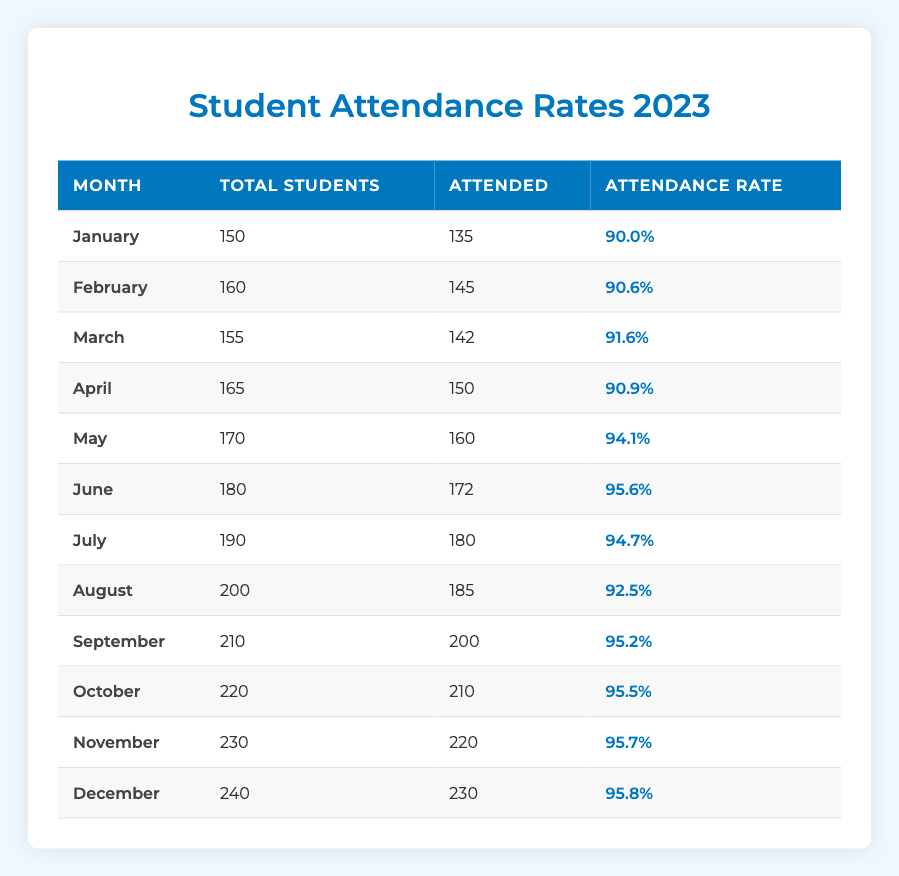What is the attendance rate for March? In the "March" row, the "Attendance Rate" is listed as 91.6%.
Answer: 91.6% How many students attended in June? The "Attended" column for "June" shows the value 172.
Answer: 172 What is the average attendance rate from January to April? The attendance rates for January to April are 90.0%, 90.6%, 91.6%, and 90.9%. Summing these gives 90.0 + 90.6 + 91.6 + 90.9 = 363.1. There are 4 months, so the average is 363.1 / 4 = 90.775%.
Answer: 90.775% Did student attendance peak in October? Looking at the "Attended" column, October has 210 students attended while November has 220. Therefore, October did not have the highest attendance.
Answer: No What is the total number of students who attended in the second half of the year (July to December)? The attended numbers for July to December are 180, 185, 200, 210, 220, and 230, respectively. Adding these gives 180 + 185 + 200 + 210 + 220 + 230 = 1225.
Answer: 1225 Was the attendance rate in May higher than that in January? The attendance rate for May is 94.1% and for January it is 90.0%. Since 94.1% is greater than 90.0%, May had a higher attendance rate.
Answer: Yes What percentage of students attended in December compared to the total number of students in that month? In December, 230 attended out of 240 total students. The ratio is 230/240 = 0.9583. Multiplying by 100 gives an attendance rate of 95.83%.
Answer: 95.83% In which month did the attendance rate first exceed 95%? Looking through the attendance rates, the first instance where the rate exceeds 95% is in June, where it is 95.6%.
Answer: June What is the total increase in students attending from February to November? In February, the attended number is 145, and in November, it is 220. The increase is 220 - 145 = 75.
Answer: 75 